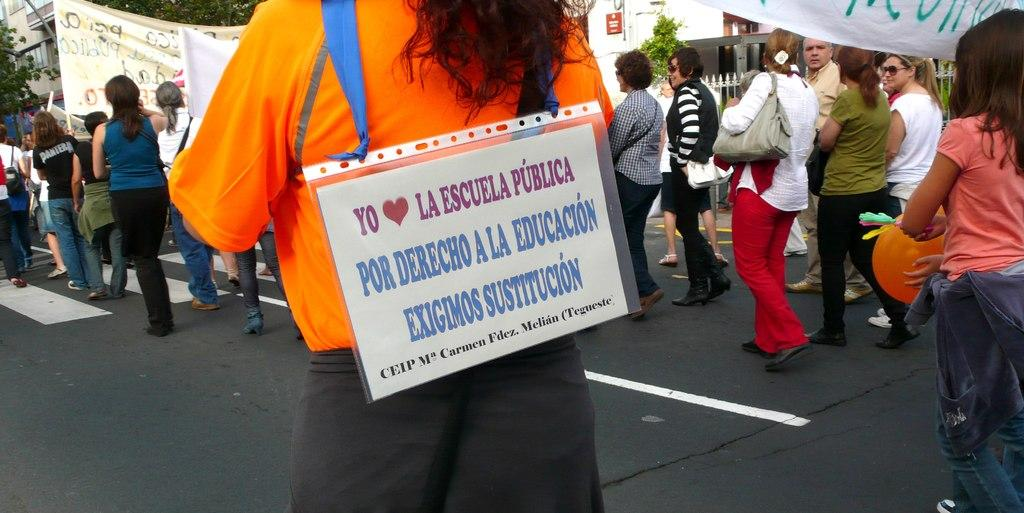How many people are in the image? There are many persons in the image. What are the persons in the image doing? The persons are walking on the road and holding banners and placards. What can be seen in the background of the image? There are trees, buildings, and fencing in the background of the image. What type of sticks are the ducks using to remember their lines in the image? There are no ducks or sticks present in the image, and therefore no such activity can be observed. 